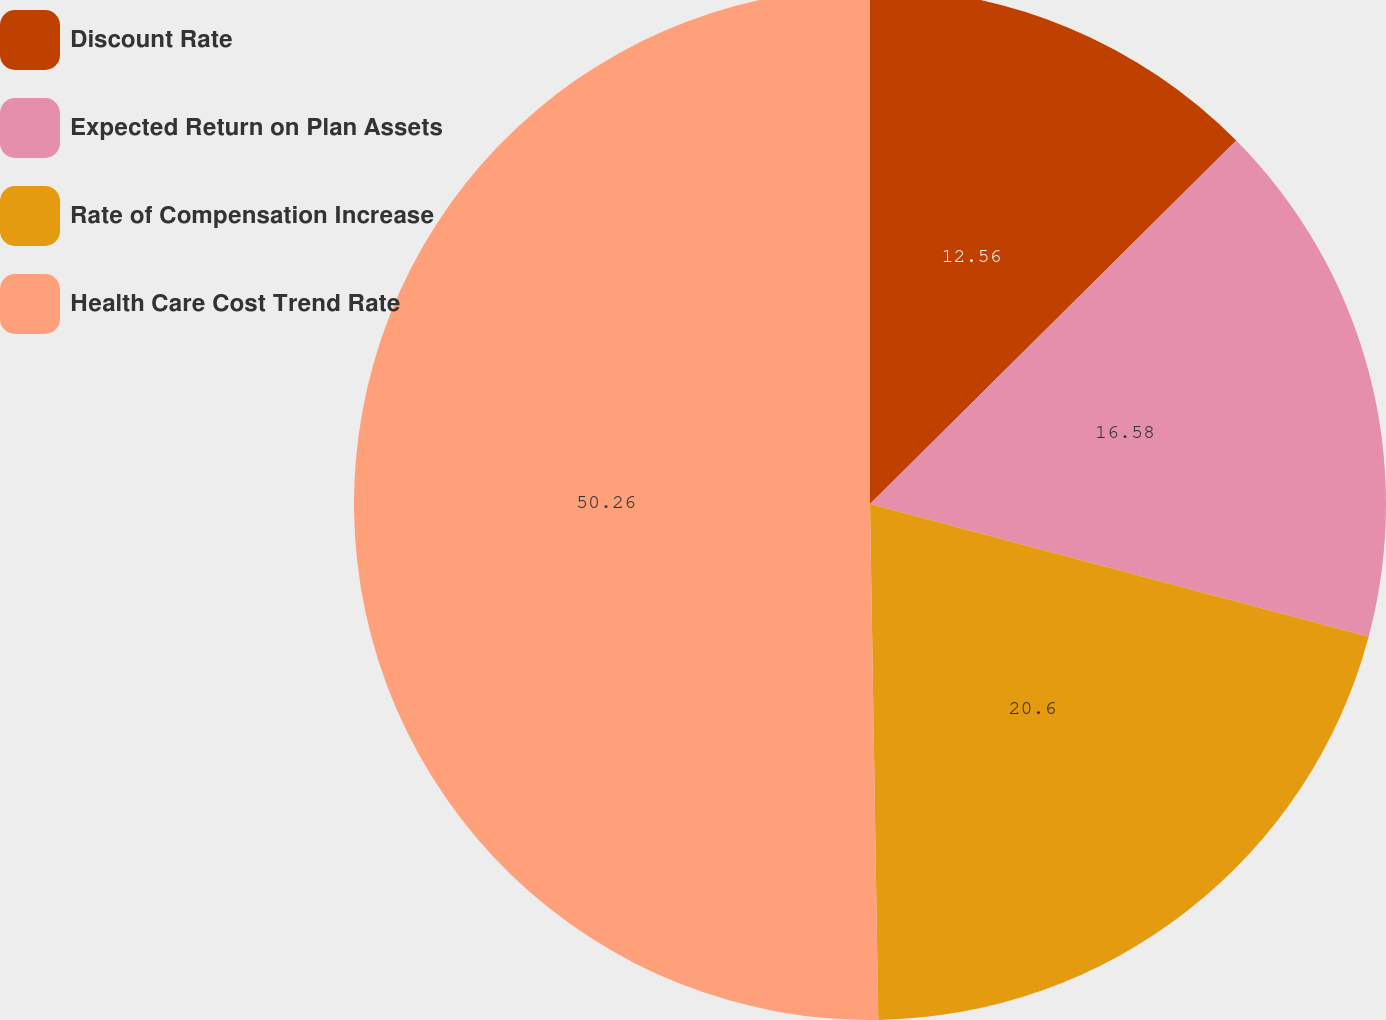Convert chart to OTSL. <chart><loc_0><loc_0><loc_500><loc_500><pie_chart><fcel>Discount Rate<fcel>Expected Return on Plan Assets<fcel>Rate of Compensation Increase<fcel>Health Care Cost Trend Rate<nl><fcel>12.56%<fcel>16.58%<fcel>20.6%<fcel>50.25%<nl></chart> 